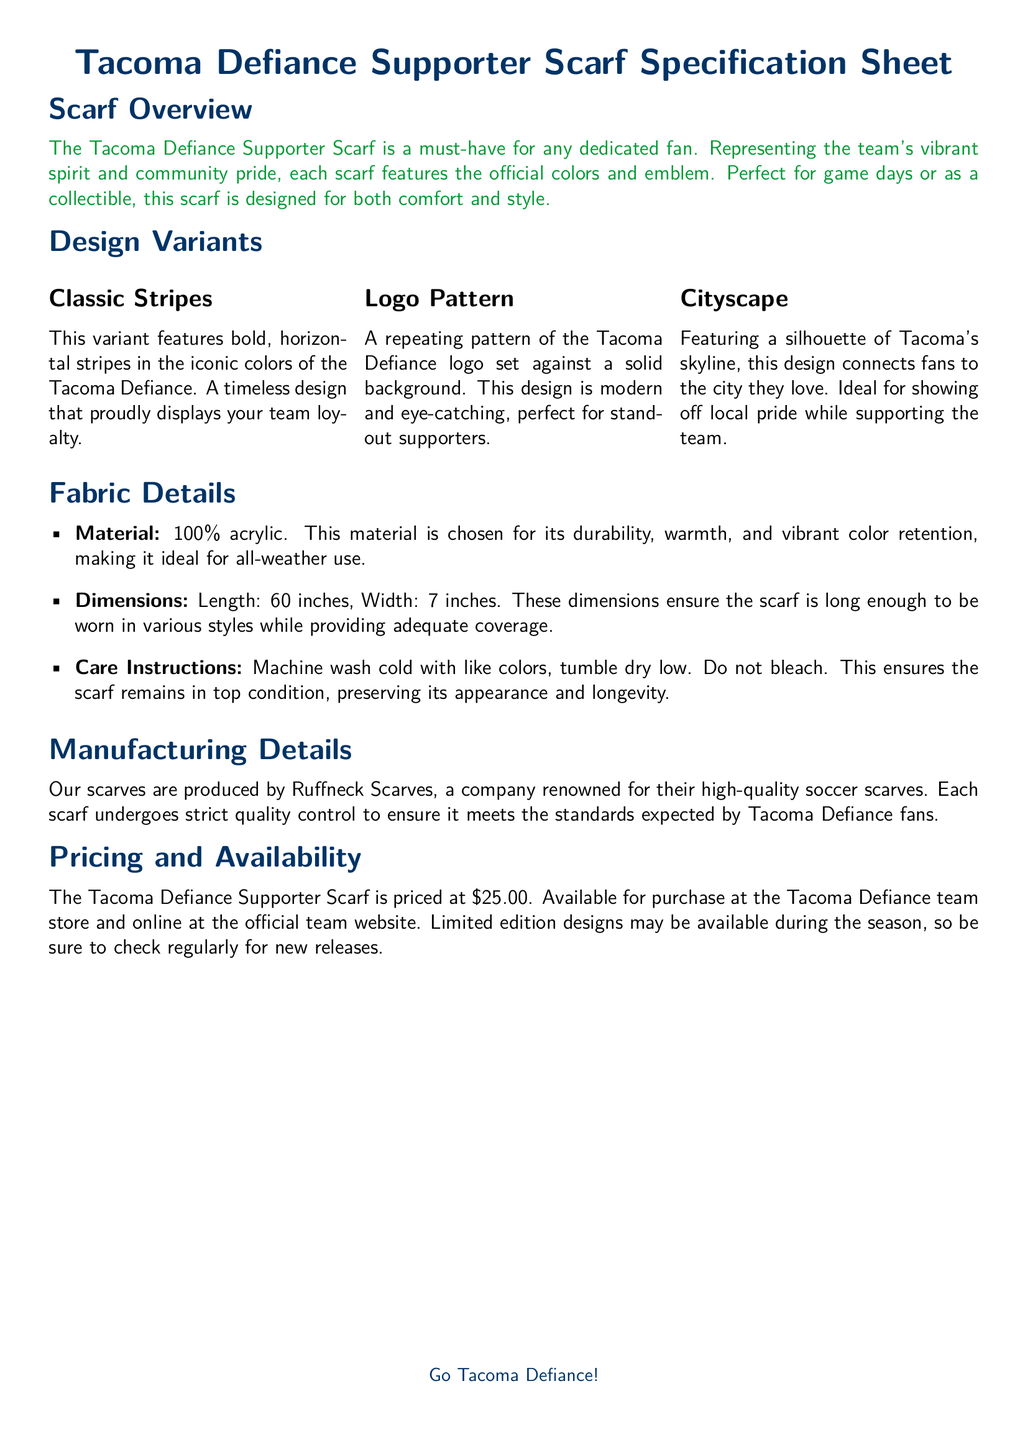What are the official colors of the Tacoma Defiance? The document mentions that the scarf features the official colors, but does not specify them explicitly. However, they can be inferred from the document's design mentions.
Answer: Defiance blue and defiance green What material is used for the scarf? The material is explicitly stated in the fabric details section of the document.
Answer: 100% acrylic What are the dimensions of the scarf? The scarf's dimensions are provided in the fabric details section, detailing its length and width.
Answer: 60 inches long and 7 inches wide Who manufactures the scarves? The document clearly states the manufacturer in the manufacturing details section.
Answer: Ruffneck Scarves How much does the Tacoma Defiance Supporter Scarf cost? The pricing information is directly provided in the pricing and availability section of the document.
Answer: $25.00 What is one design variant of the scarf? The document lists multiple design variants in the design variants section, allowing for identification of at least one option.
Answer: Classic Stripes What care instructions are provided for the scarf? The care instructions are explicitly listed under the fabric details section, indicating how to maintain the scarf.
Answer: Machine wash cold with like colors, tumble dry low What does the Cityscape design feature? The Cityscape design is described in the design variants section, highlighting its visual representation.
Answer: A silhouette of Tacoma's skyline How are the scarves assured of quality? The document mentions that strict quality control is undertaken for the scarves from the manufacturer, ensuring standards are met.
Answer: Strict quality control 